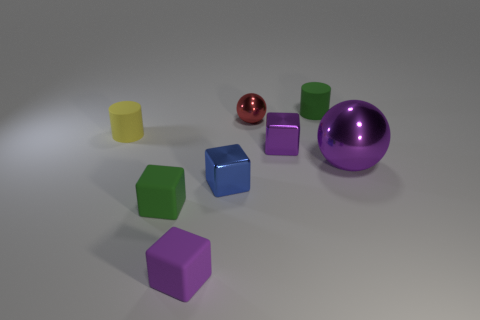How many small objects are there?
Ensure brevity in your answer.  7. There is a yellow object that is the same size as the blue metal cube; what is its material?
Keep it short and to the point. Rubber. Are there any brown metallic cubes that have the same size as the purple rubber block?
Offer a terse response. No. Does the tiny rubber cylinder on the right side of the tiny metal ball have the same color as the sphere in front of the yellow object?
Your answer should be very brief. No. What number of metallic things are either large purple things or tiny blue objects?
Offer a very short reply. 2. There is a green thing that is behind the purple metallic thing on the left side of the green cylinder; what number of small green cylinders are in front of it?
Your response must be concise. 0. There is another sphere that is made of the same material as the purple sphere; what is its size?
Give a very brief answer. Small. How many tiny rubber cylinders have the same color as the tiny metal sphere?
Your answer should be compact. 0. Is the size of the cylinder that is on the right side of the yellow cylinder the same as the small purple shiny thing?
Provide a succinct answer. Yes. What color is the metallic thing that is both right of the red metallic sphere and to the left of the big purple object?
Ensure brevity in your answer.  Purple. 